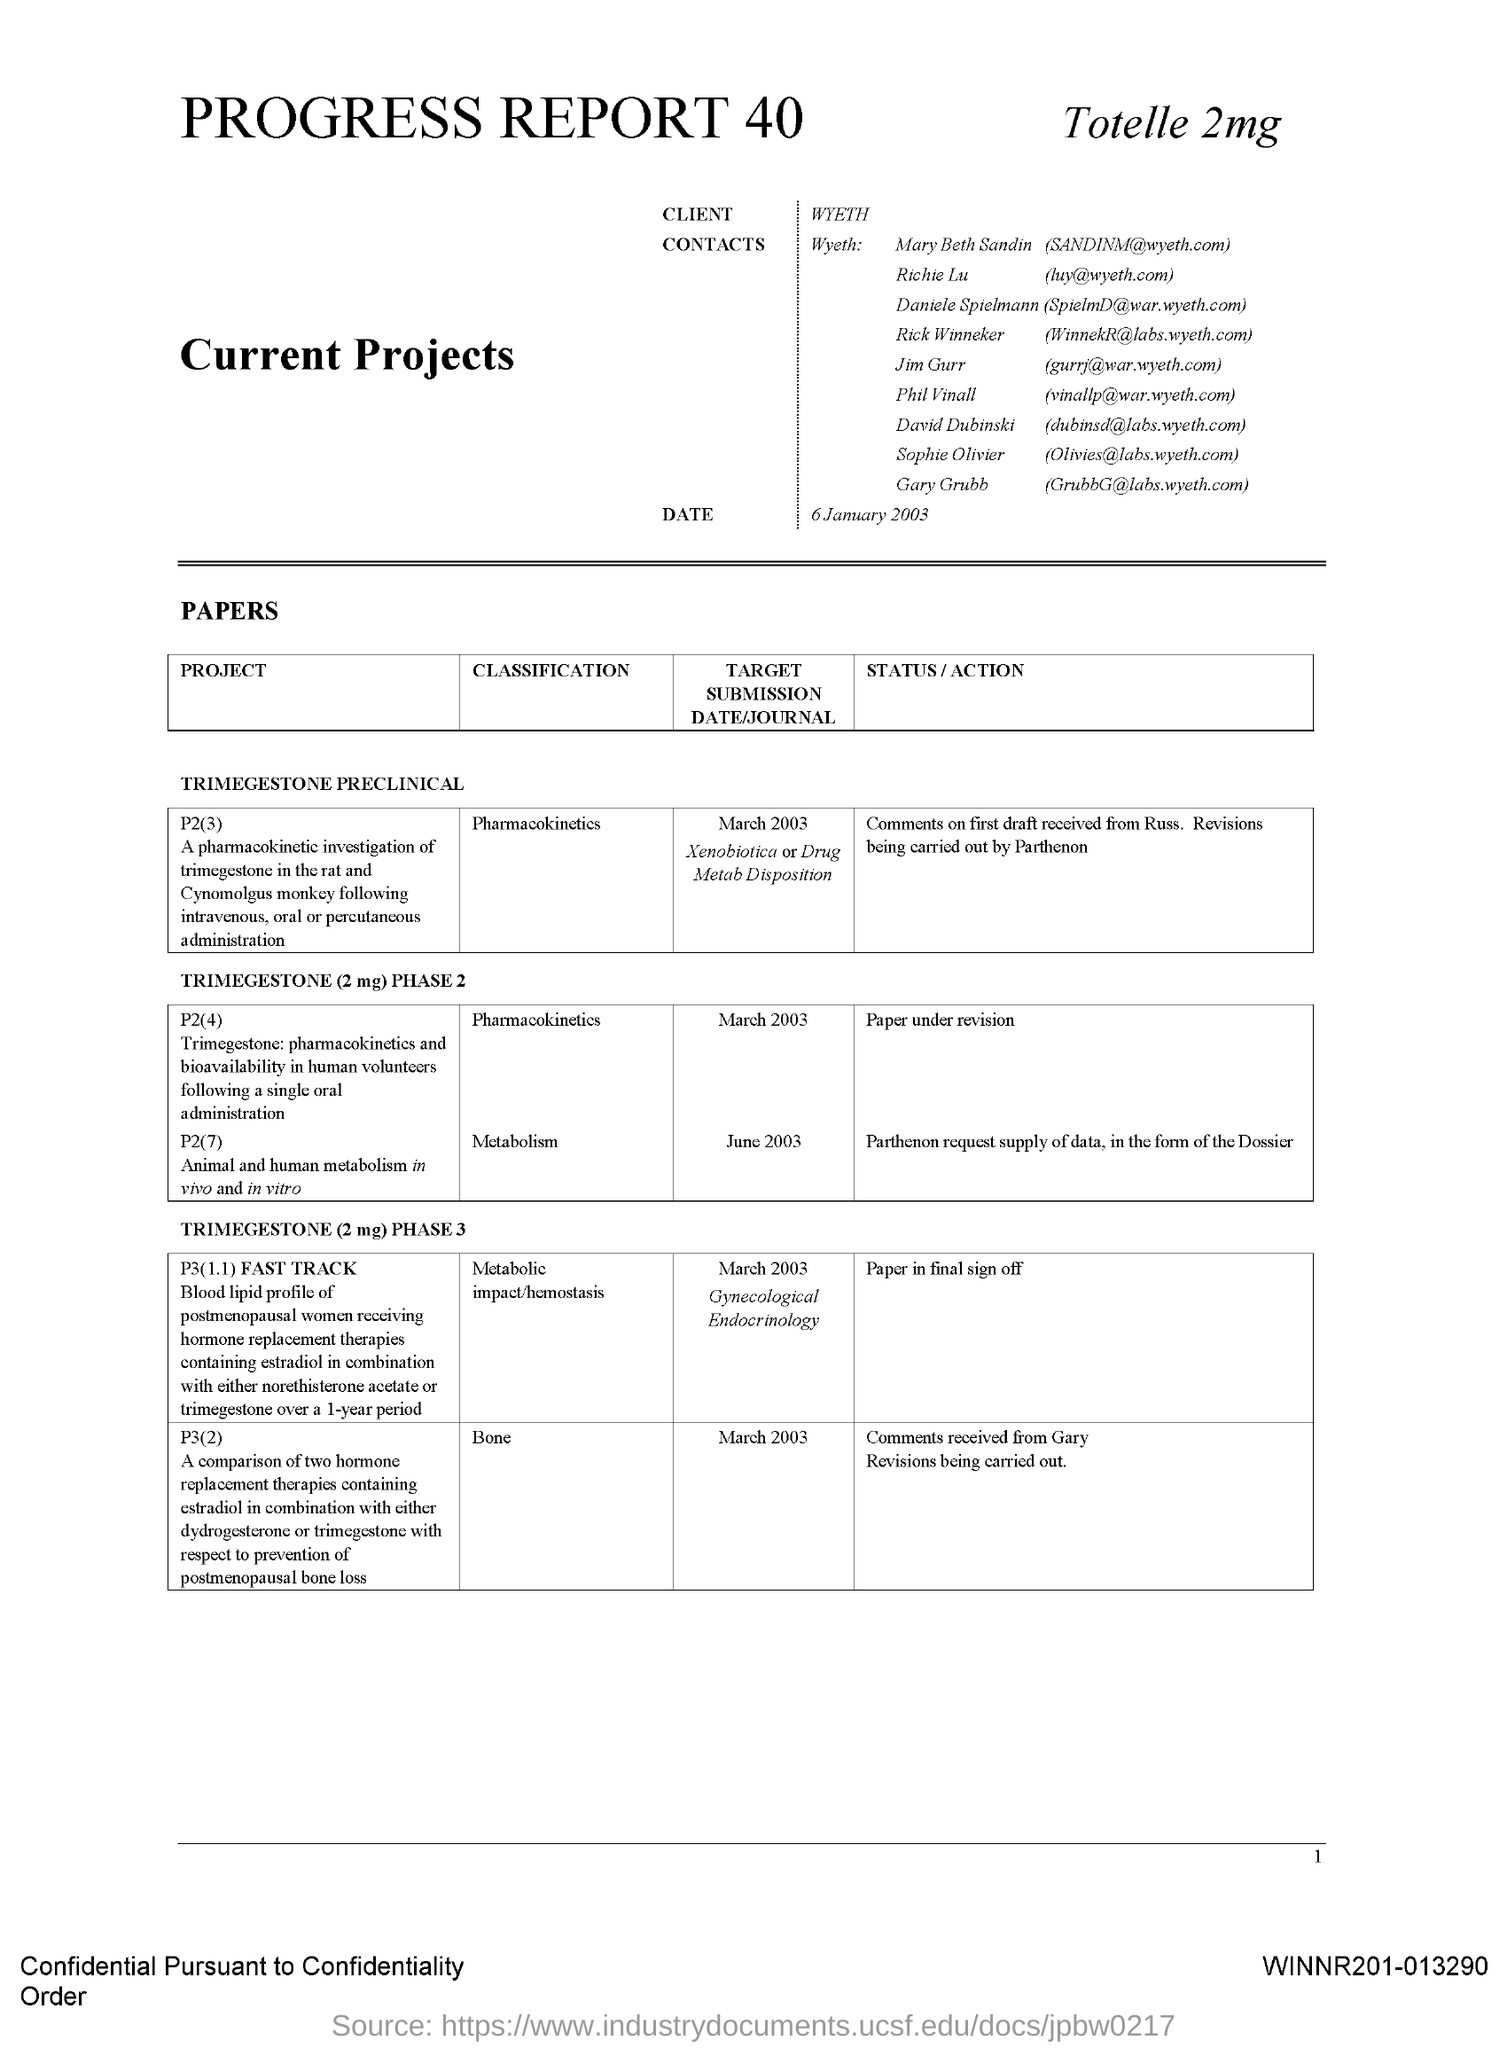Point out several critical features in this image. The client is Wyeth. 